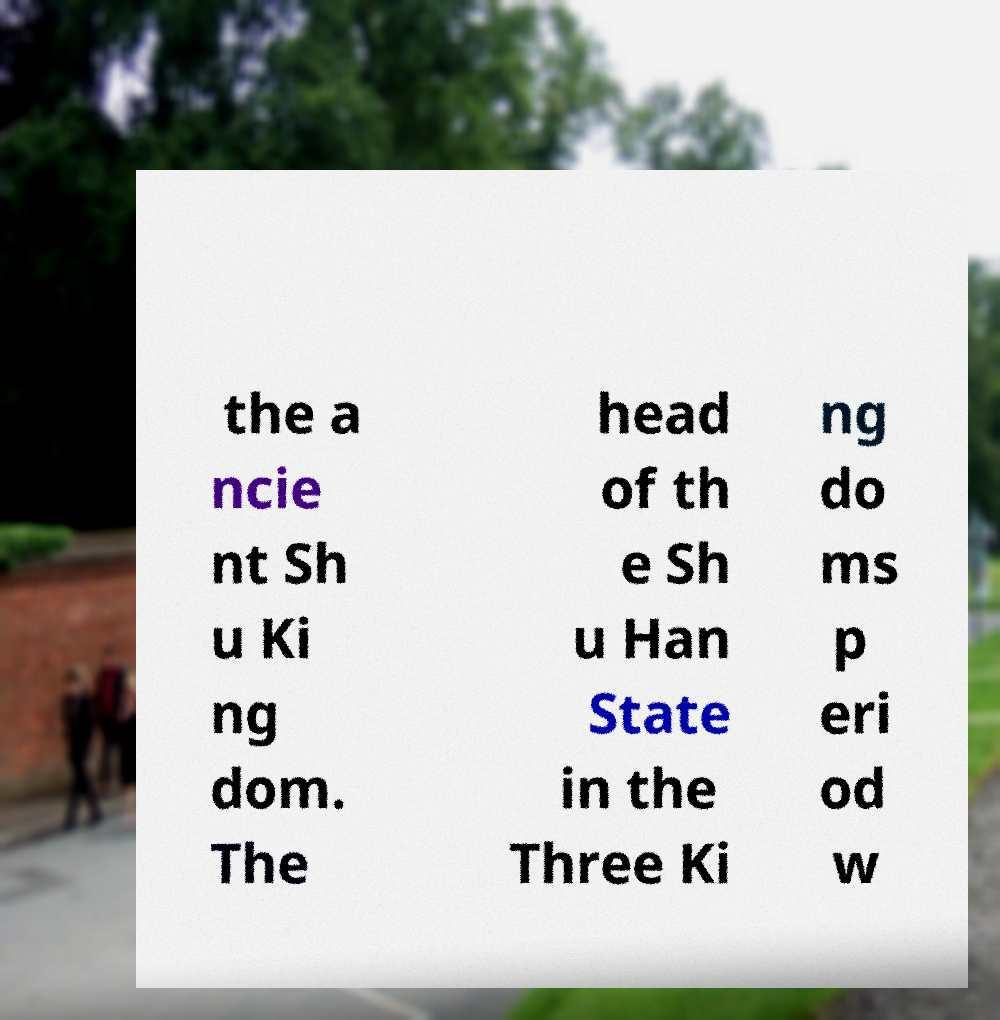For documentation purposes, I need the text within this image transcribed. Could you provide that? the a ncie nt Sh u Ki ng dom. The head of th e Sh u Han State in the Three Ki ng do ms p eri od w 